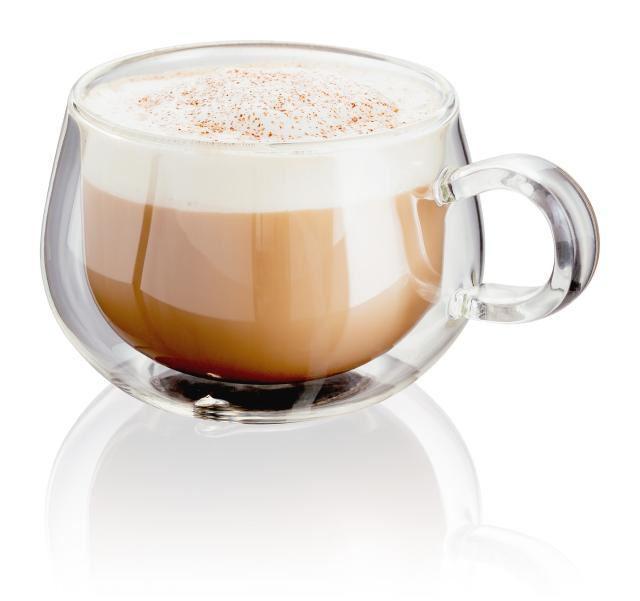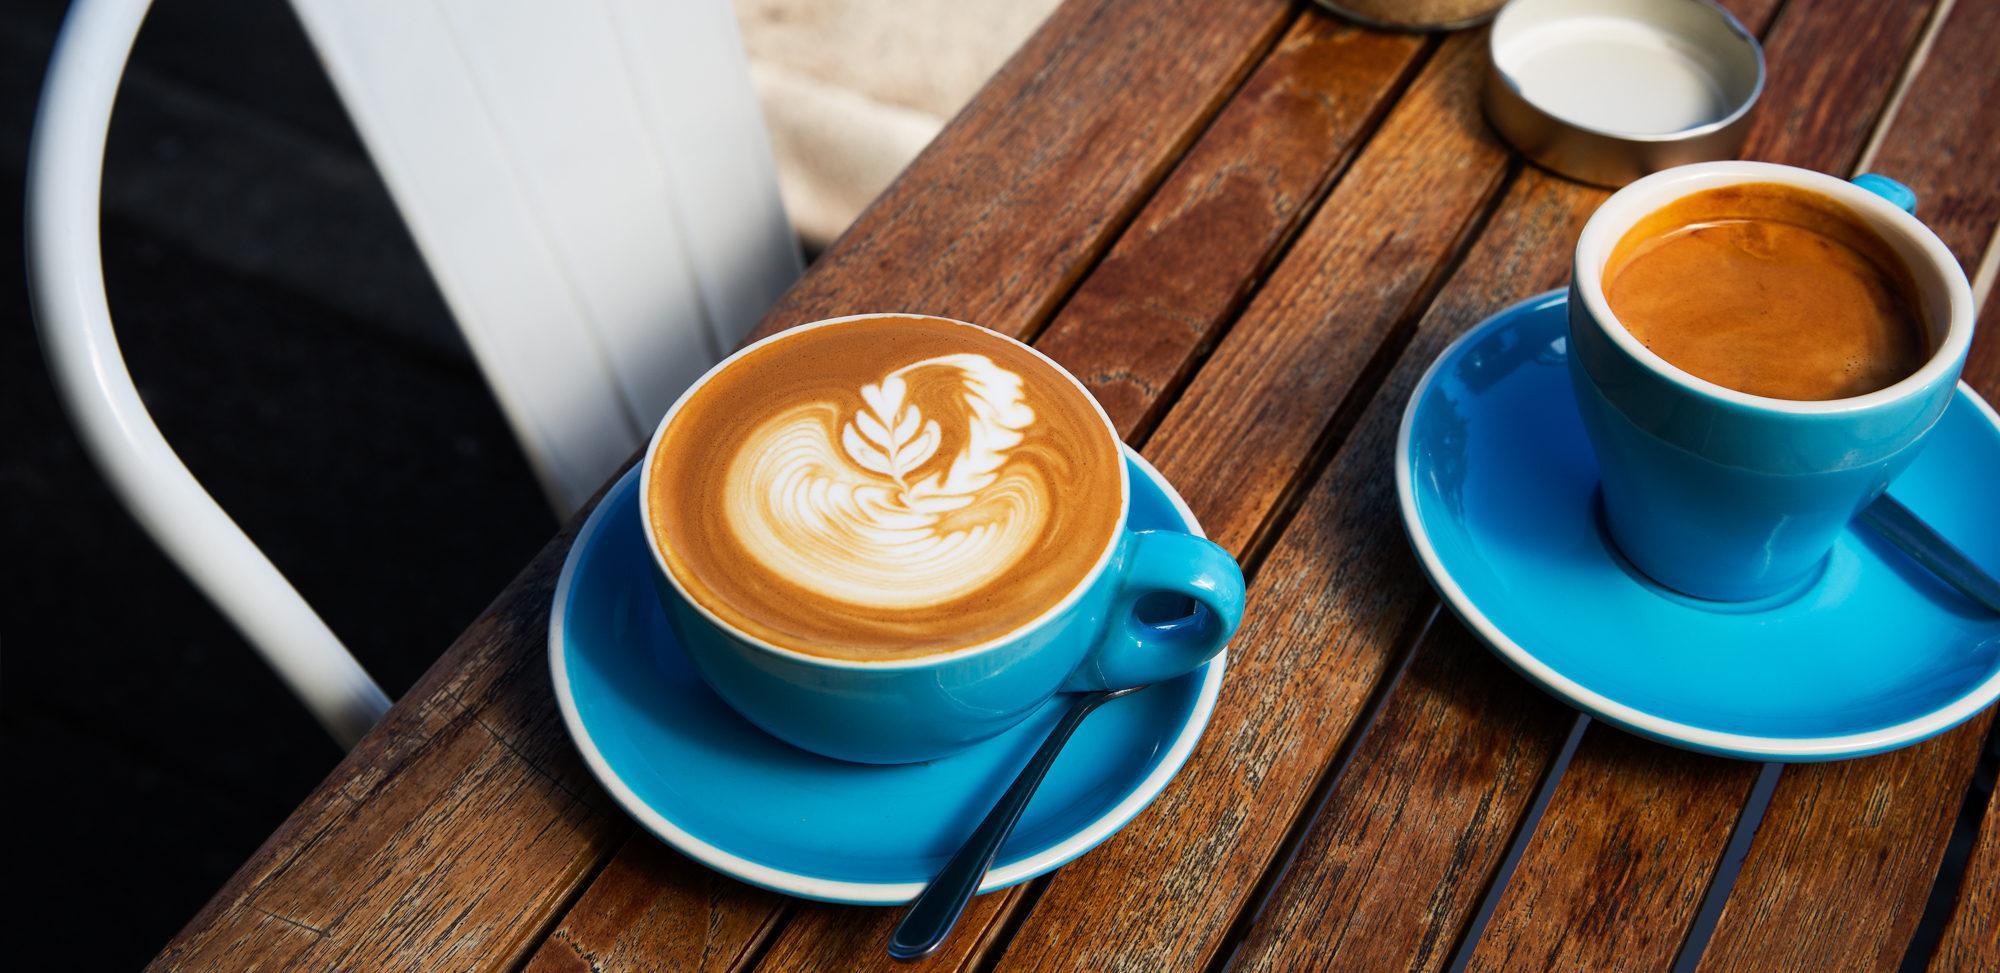The first image is the image on the left, the second image is the image on the right. Examine the images to the left and right. Is the description "The left and right image contains a total of three full coffee cups." accurate? Answer yes or no. Yes. The first image is the image on the left, the second image is the image on the right. Evaluate the accuracy of this statement regarding the images: "There is a milk design in a coffee.". Is it true? Answer yes or no. Yes. 